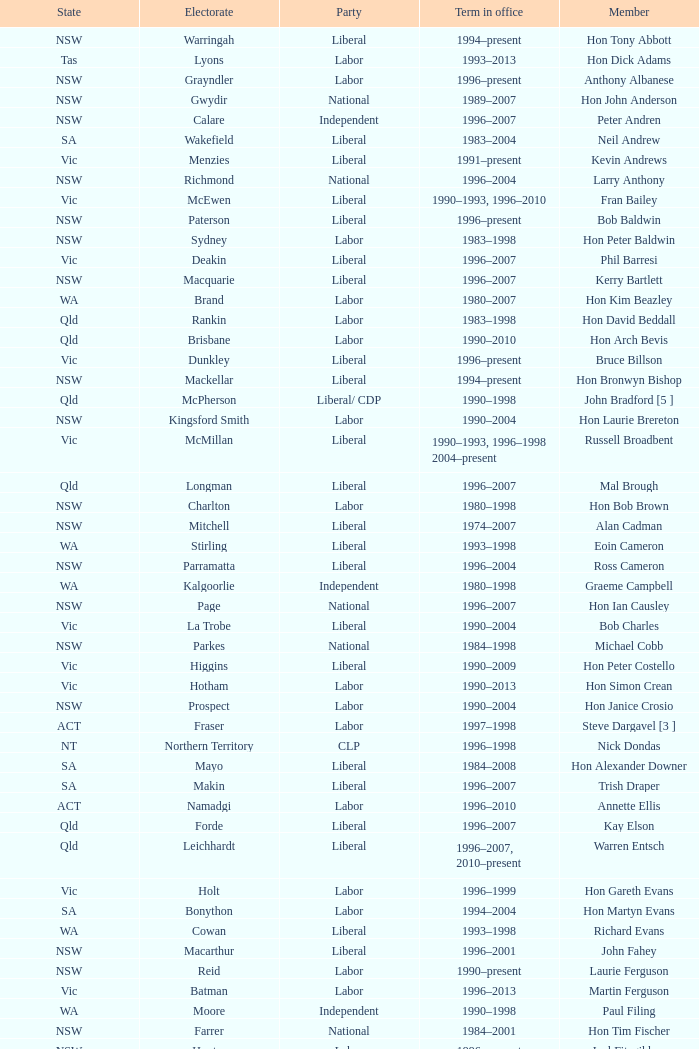What state did Hon David Beddall belong to? Qld. 